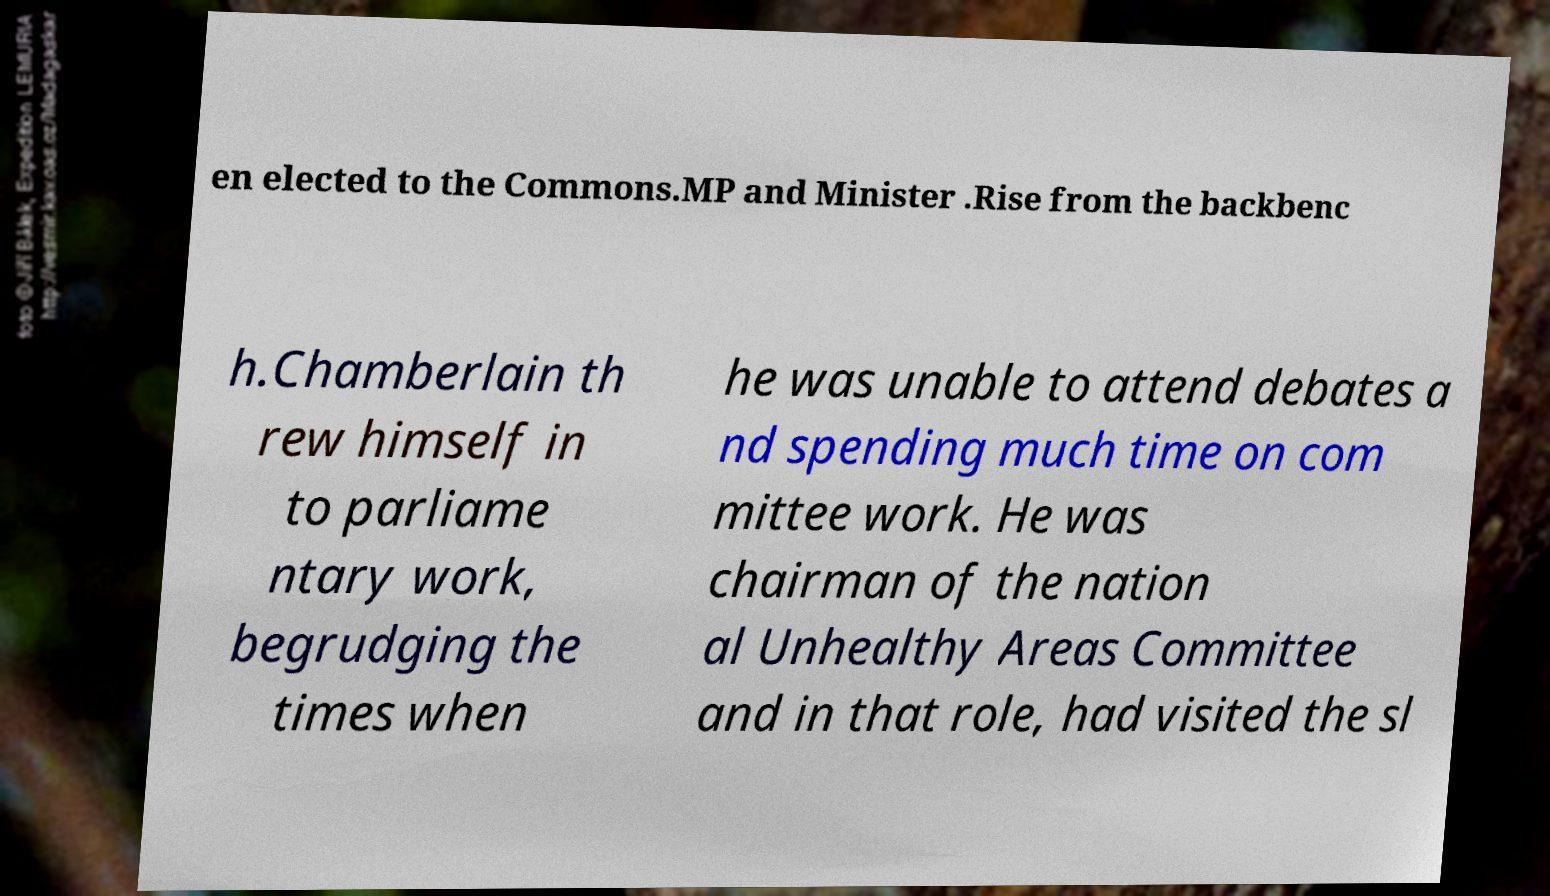Can you read and provide the text displayed in the image?This photo seems to have some interesting text. Can you extract and type it out for me? en elected to the Commons.MP and Minister .Rise from the backbenc h.Chamberlain th rew himself in to parliame ntary work, begrudging the times when he was unable to attend debates a nd spending much time on com mittee work. He was chairman of the nation al Unhealthy Areas Committee and in that role, had visited the sl 